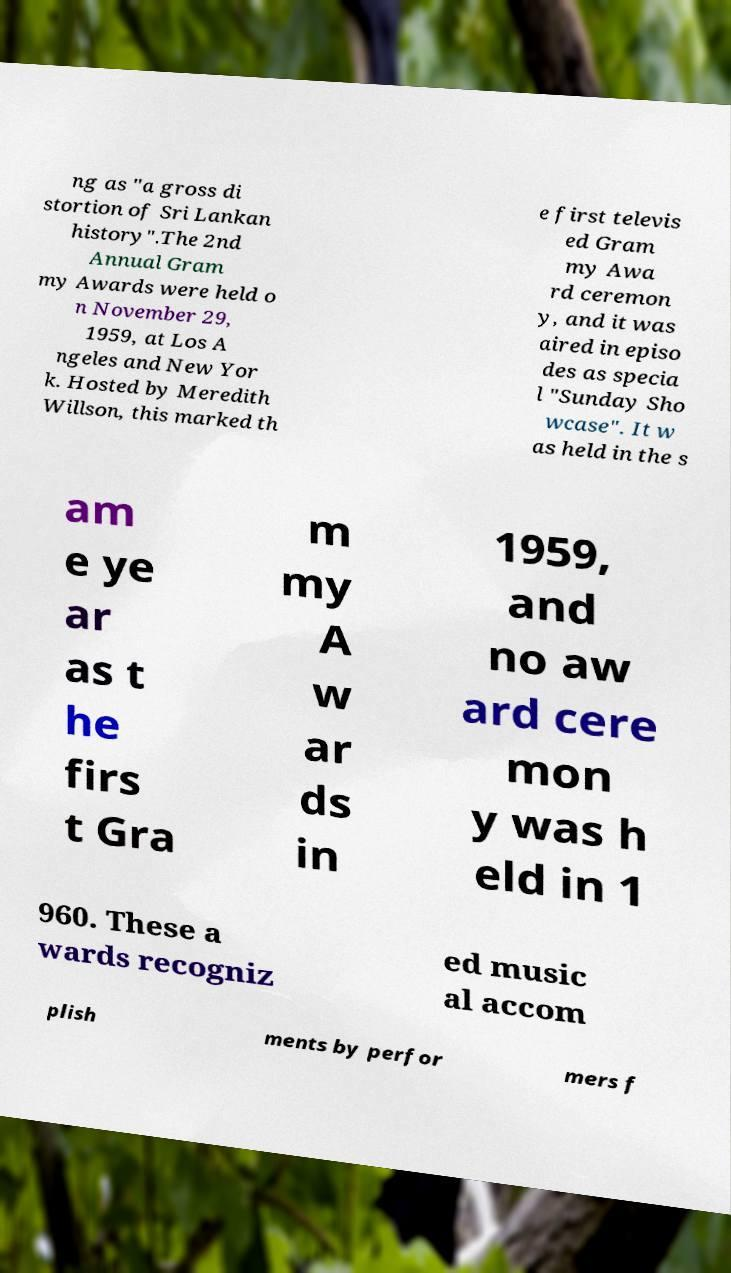Could you assist in decoding the text presented in this image and type it out clearly? ng as "a gross di stortion of Sri Lankan history".The 2nd Annual Gram my Awards were held o n November 29, 1959, at Los A ngeles and New Yor k. Hosted by Meredith Willson, this marked th e first televis ed Gram my Awa rd ceremon y, and it was aired in episo des as specia l "Sunday Sho wcase". It w as held in the s am e ye ar as t he firs t Gra m my A w ar ds in 1959, and no aw ard cere mon y was h eld in 1 960. These a wards recogniz ed music al accom plish ments by perfor mers f 